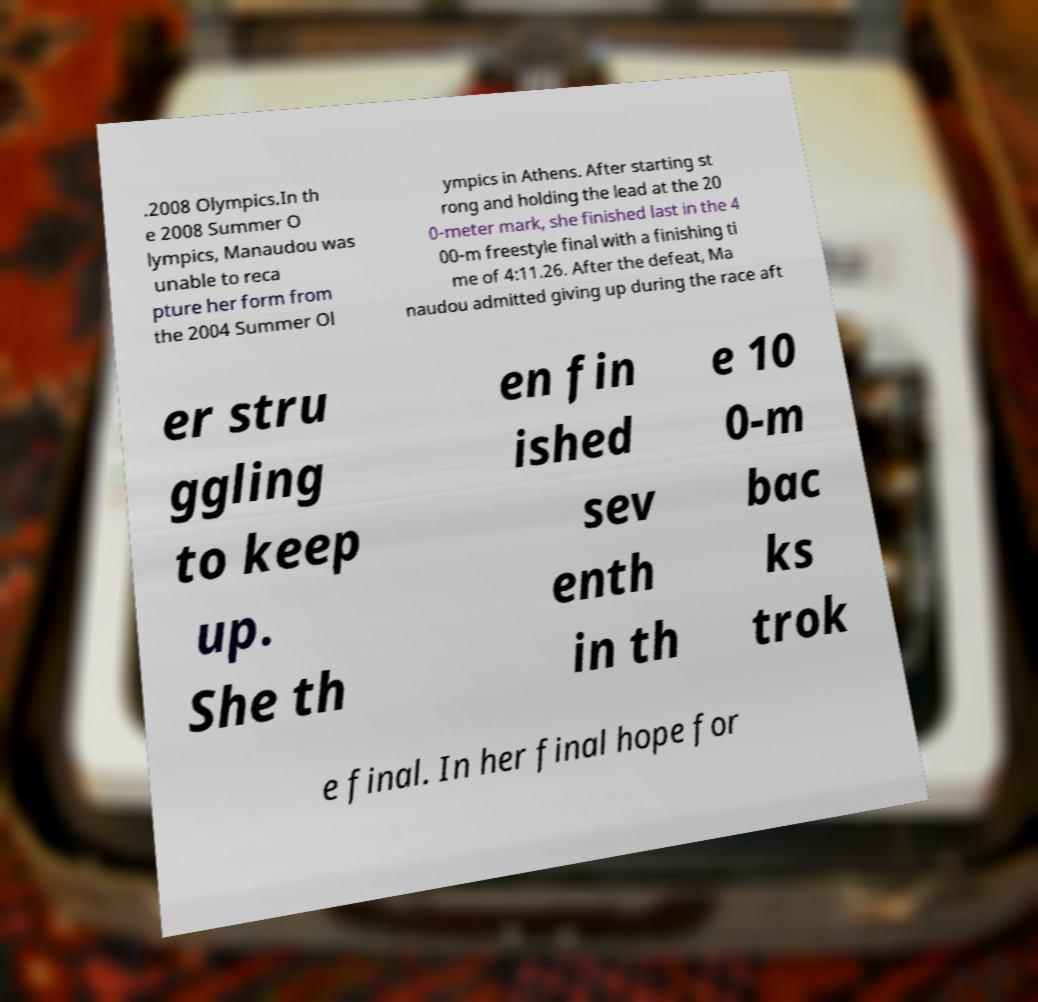Please read and relay the text visible in this image. What does it say? .2008 Olympics.In th e 2008 Summer O lympics, Manaudou was unable to reca pture her form from the 2004 Summer Ol ympics in Athens. After starting st rong and holding the lead at the 20 0-meter mark, she finished last in the 4 00-m freestyle final with a finishing ti me of 4:11.26. After the defeat, Ma naudou admitted giving up during the race aft er stru ggling to keep up. She th en fin ished sev enth in th e 10 0-m bac ks trok e final. In her final hope for 